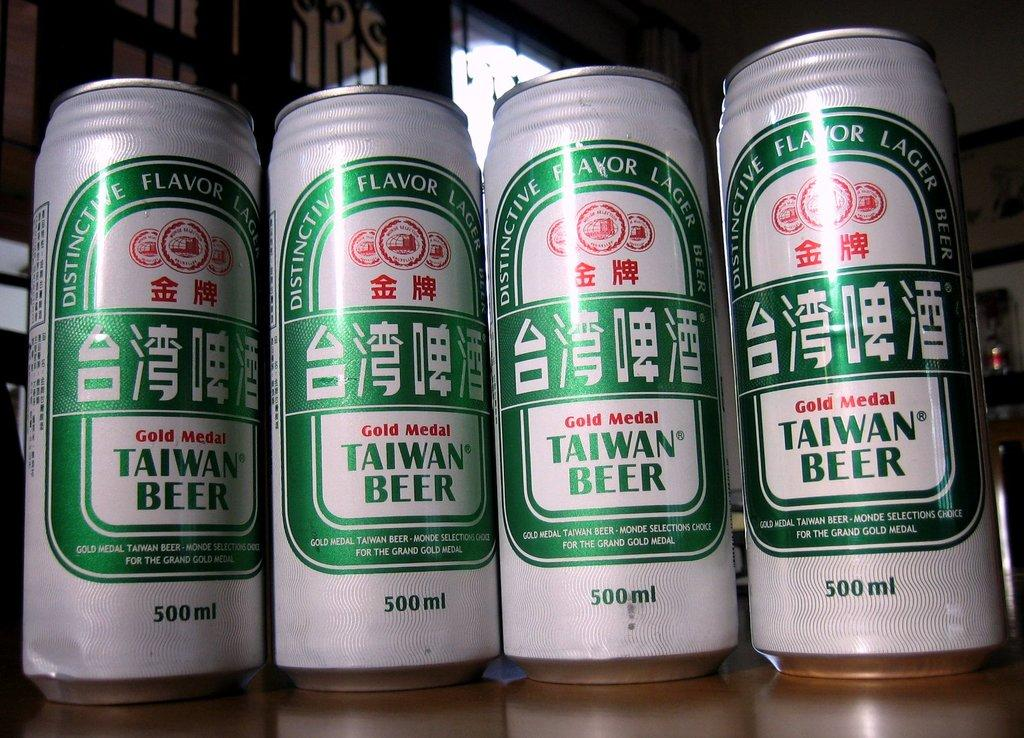<image>
Write a terse but informative summary of the picture. Four cans of Taiwan Beer, a gold medal winner, sit next to each other. 